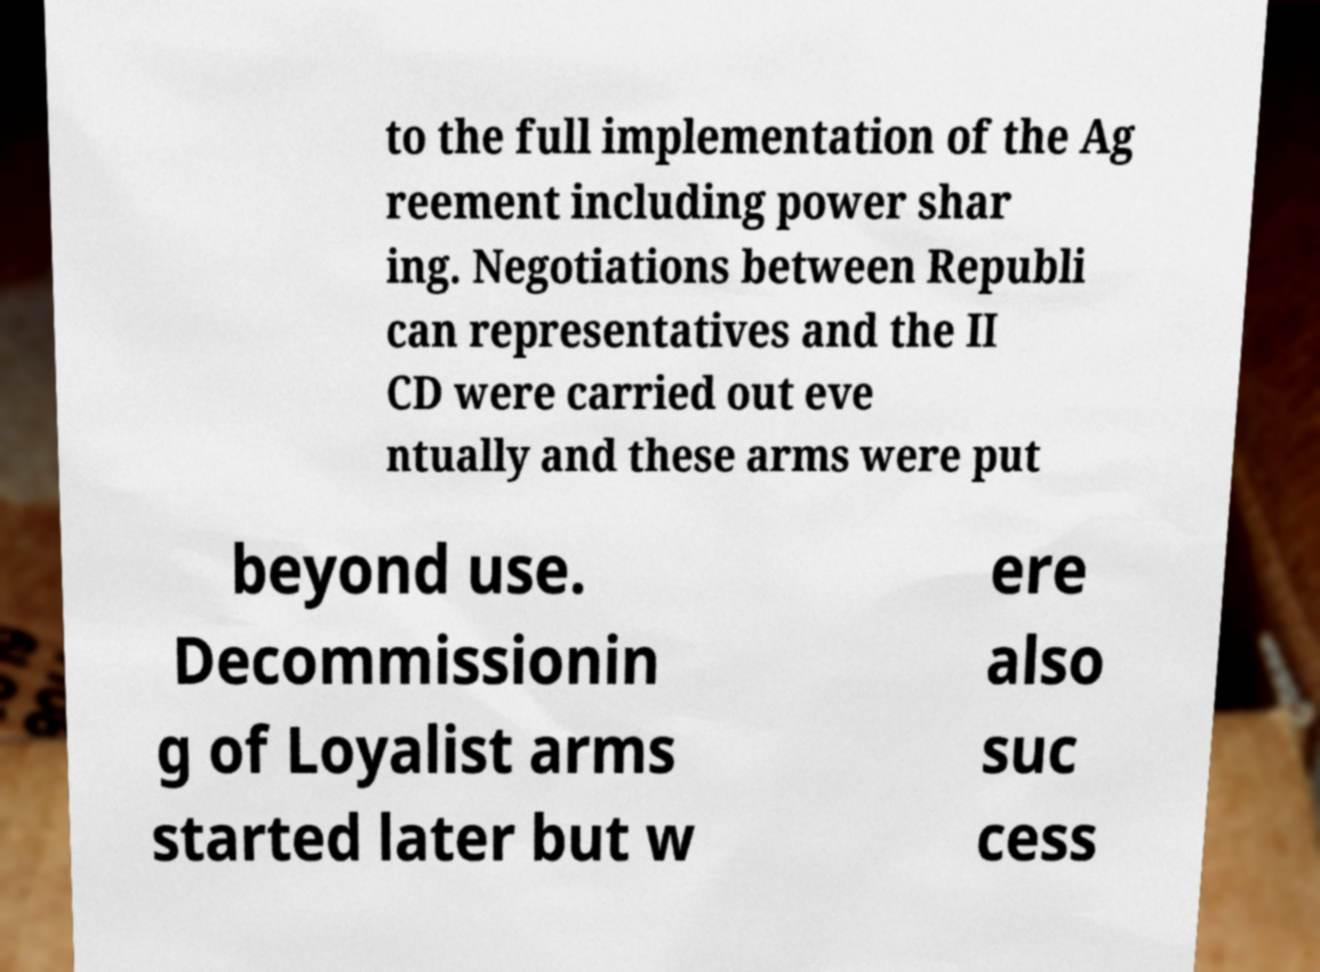Please read and relay the text visible in this image. What does it say? to the full implementation of the Ag reement including power shar ing. Negotiations between Republi can representatives and the II CD were carried out eve ntually and these arms were put beyond use. Decommissionin g of Loyalist arms started later but w ere also suc cess 